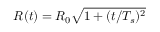<formula> <loc_0><loc_0><loc_500><loc_500>R ( t ) = R _ { 0 } \sqrt { 1 + ( t / T _ { s } ) ^ { 2 } }</formula> 